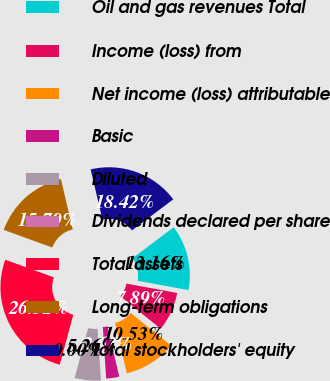<chart> <loc_0><loc_0><loc_500><loc_500><pie_chart><fcel>Oil and gas revenues Total<fcel>Income (loss) from<fcel>Net income (loss) attributable<fcel>Basic<fcel>Diluted<fcel>Dividends declared per share<fcel>Total assets<fcel>Long-term obligations<fcel>Total stockholders' equity<nl><fcel>13.16%<fcel>7.89%<fcel>10.53%<fcel>2.63%<fcel>5.26%<fcel>0.0%<fcel>26.32%<fcel>15.79%<fcel>18.42%<nl></chart> 